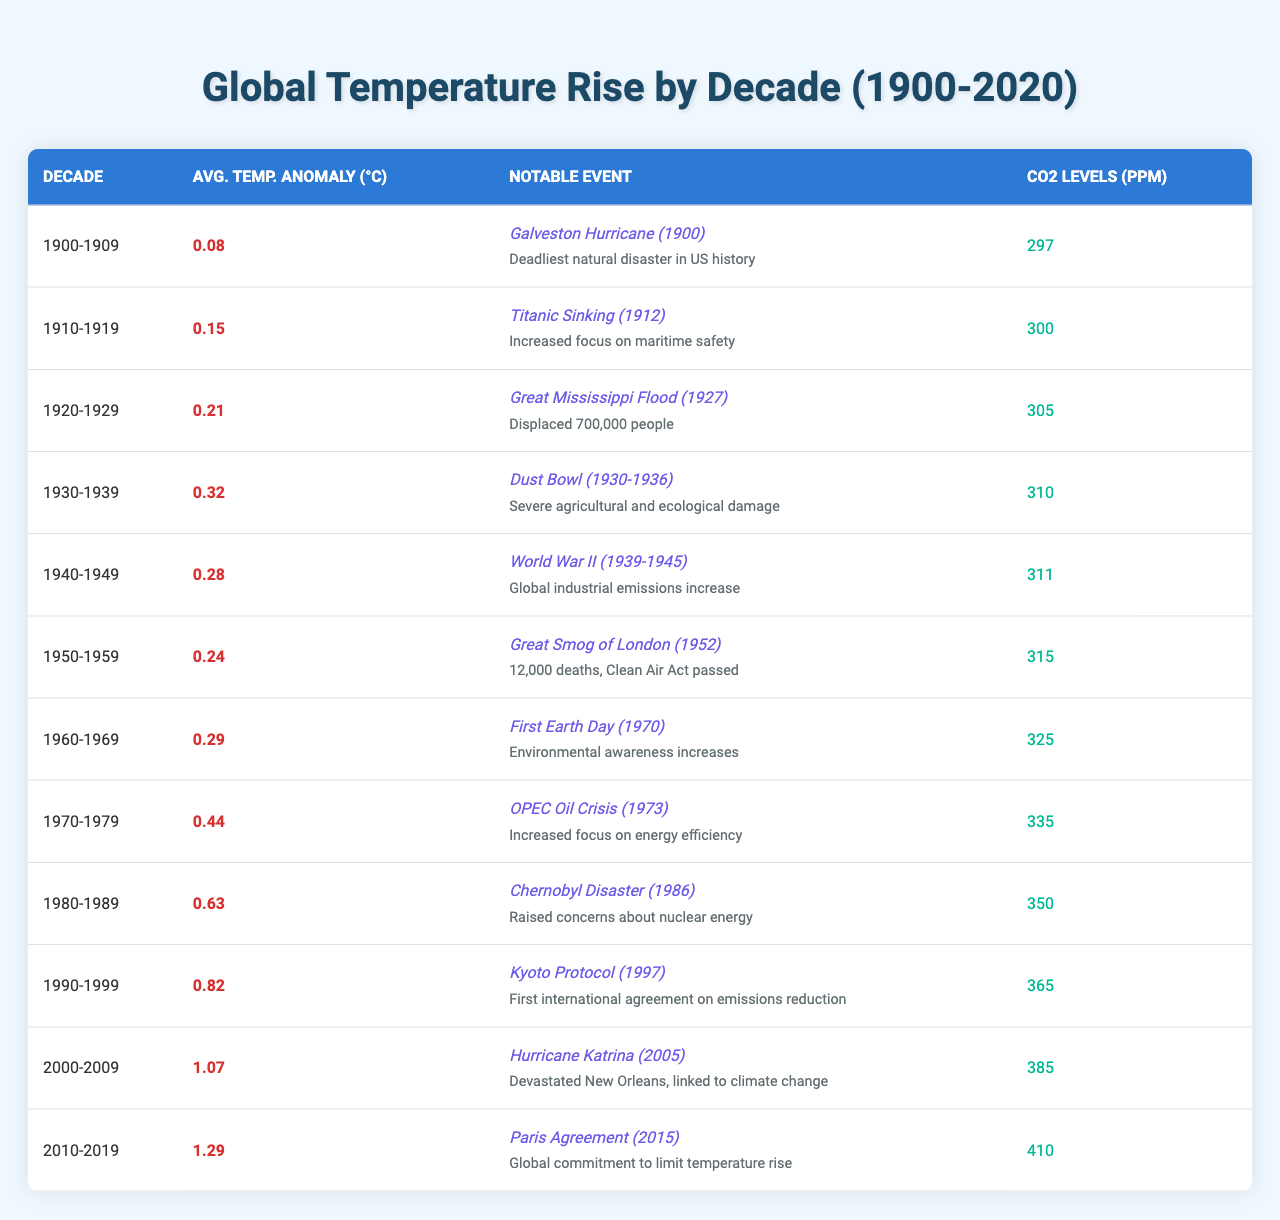What was the average temperature anomaly in the 1980-1989 decade? The average temperature anomaly for the 1980-1989 decade is listed in the table as 0.63°C.
Answer: 0.63°C What notable event occurred in the decade of 1940-1949? The table shows that the notable event for 1940-1949 was World War II.
Answer: World War II What was the CO2 level in parts per million during the 2000-2009 decade? The table lists the CO2 levels for the 2000-2009 decade as 385 ppm.
Answer: 385 ppm Which decade experienced the highest average temperature anomaly? By comparing the average temperature anomalies across decades, the highest is 1.29°C for the 2010-2019 decade.
Answer: 2010-2019 Was there an event that had a significant impact on environmental awareness in the 1970s? Yes, the table notes that the First Earth Day in 1970 significantly increased environmental awareness.
Answer: Yes What is the difference in CO2 levels between the decades of 1950-1959 and 1990-1999? The CO2 levels were 315 ppm for 1950-1959 and 365 ppm for 1990-1999. The difference is calculated as 365 - 315 = 50 ppm.
Answer: 50 ppm If we average the average temperature anomalies from 1900-1949, what do we get? The average temperature anomalies for 1900-1949 are 0.08, 0.15, 0.21, 0.32, 0.28. Summing these gives 0.08 + 0.15 + 0.21 + 0.32 + 0.28 = 1.04. Dividing by 5 gives an average of 1.04/5 = 0.208°C.
Answer: 0.208°C Was there an event related to climate change in the decade of 2000-2009? Yes, the table indicates that Hurricane Katrina, which devastated New Orleans and was linked to climate change, occurred in 2005.
Answer: Yes What trend can be observed in the average temperature anomalies from 1900-2020? The table shows a consistent rise in average temperature anomalies from 0.08°C in 1900-1909 to 1.29°C in 2010-2019, indicating increasing global temperatures over the decades.
Answer: Increasing global temperatures Which decade had the most notable impact on energy efficiency? The OPEC Oil Crisis in 1973 is noted in the table as a significant event that increased focus on energy efficiency during the 1970-1979 decade.
Answer: 1970-1979 